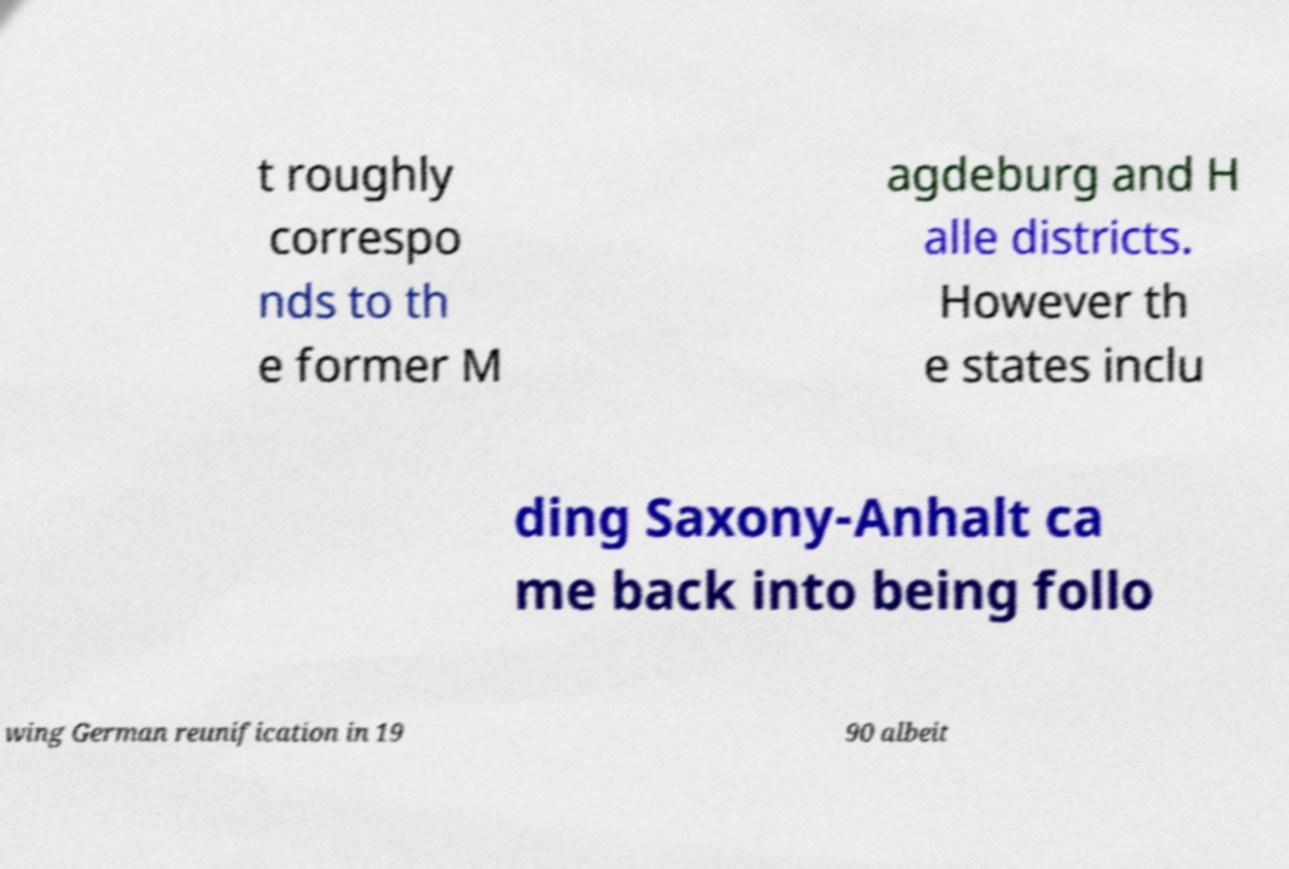Can you accurately transcribe the text from the provided image for me? t roughly correspo nds to th e former M agdeburg and H alle districts. However th e states inclu ding Saxony-Anhalt ca me back into being follo wing German reunification in 19 90 albeit 